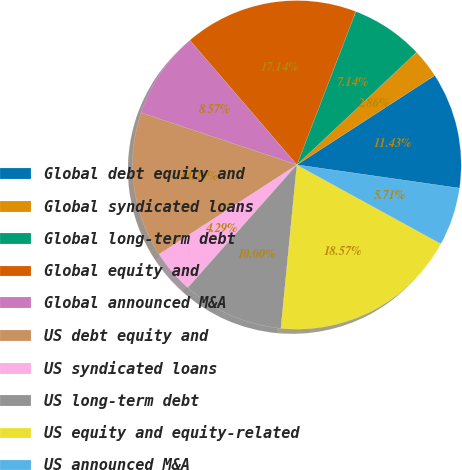Convert chart to OTSL. <chart><loc_0><loc_0><loc_500><loc_500><pie_chart><fcel>Global debt equity and<fcel>Global syndicated loans<fcel>Global long-term debt<fcel>Global equity and<fcel>Global announced M&A<fcel>US debt equity and<fcel>US syndicated loans<fcel>US long-term debt<fcel>US equity and equity-related<fcel>US announced M&A<nl><fcel>11.43%<fcel>2.86%<fcel>7.14%<fcel>17.14%<fcel>8.57%<fcel>14.29%<fcel>4.29%<fcel>10.0%<fcel>18.57%<fcel>5.71%<nl></chart> 